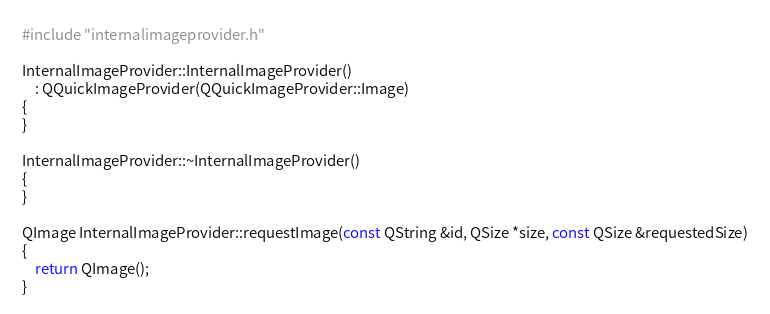<code> <loc_0><loc_0><loc_500><loc_500><_C++_>#include "internalimageprovider.h"

InternalImageProvider::InternalImageProvider()
    : QQuickImageProvider(QQuickImageProvider::Image)
{
}

InternalImageProvider::~InternalImageProvider()
{
}

QImage InternalImageProvider::requestImage(const QString &id, QSize *size, const QSize &requestedSize)
{
    return QImage();
}
</code> 